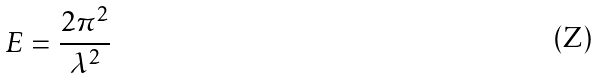<formula> <loc_0><loc_0><loc_500><loc_500>E = \frac { 2 \pi ^ { 2 } } { \lambda ^ { 2 } }</formula> 